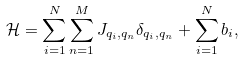Convert formula to latex. <formula><loc_0><loc_0><loc_500><loc_500>\mathcal { H } = \sum _ { i = 1 } ^ { N } \sum _ { n = 1 } ^ { M } J _ { q _ { i } , q _ { n } } \delta _ { q _ { i } , q _ { n } } + \sum _ { i = 1 } ^ { N } b _ { i } ,</formula> 